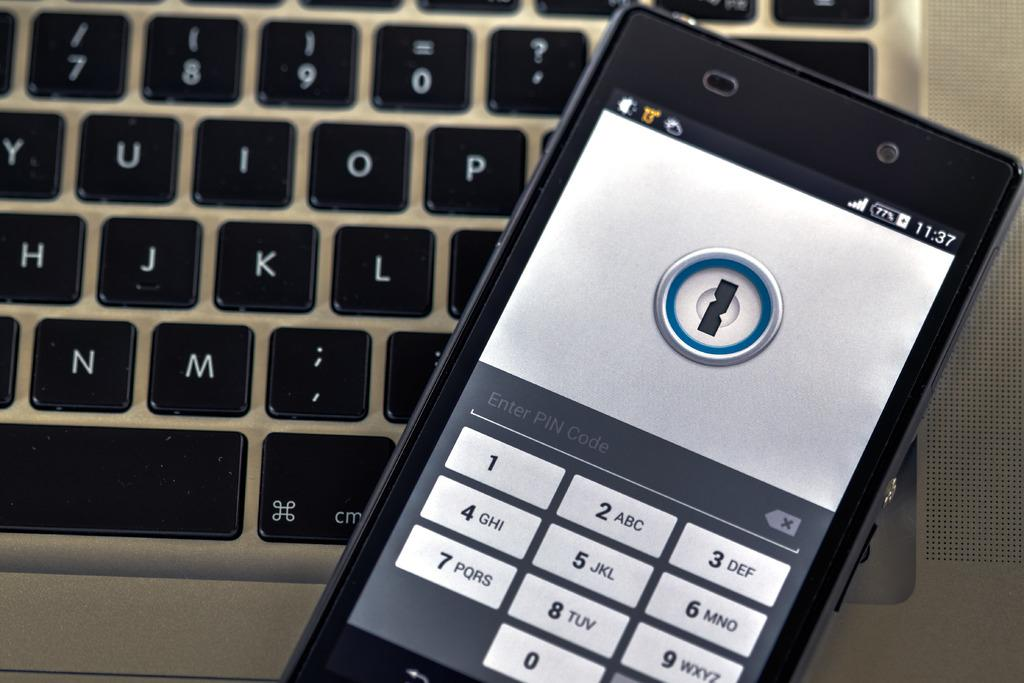<image>
Describe the image concisely. A cell phone screen displays a keypad and the written request to Enter PIN Code. 